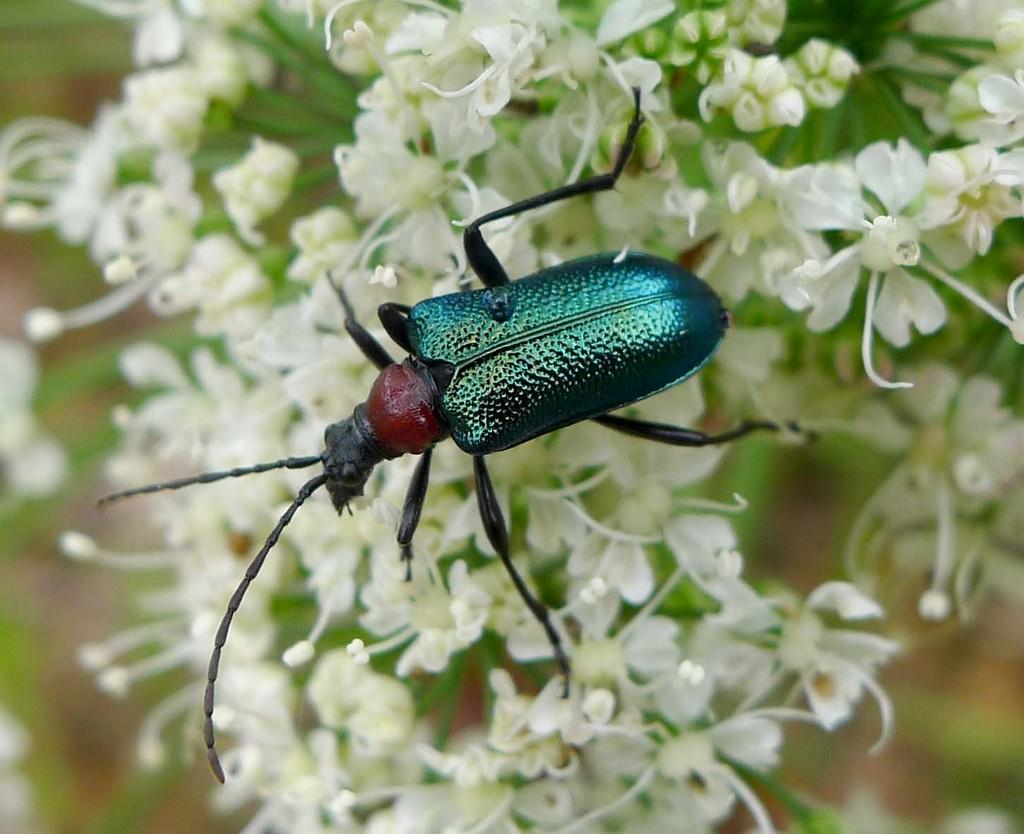Where was the picture taken? The picture was clicked outside. What is the main subject of the image? There is an insect in the center of the image, which appears to be a leaf beetle. What is the insect sitting on? The insect is on white color flowers. Can you describe the background of the image? There are other objects visible in the background of the image. What type of memory is the insect using to remember the flowers? There is no indication in the image that the insect is using any type of memory to remember the flowers. 